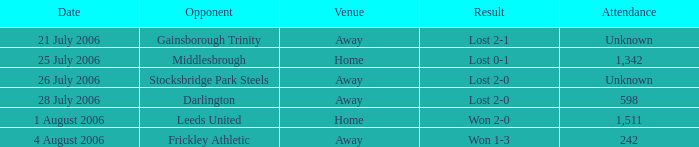Which opponent has unknown attendance, and lost 2-0? Stocksbridge Park Steels. 